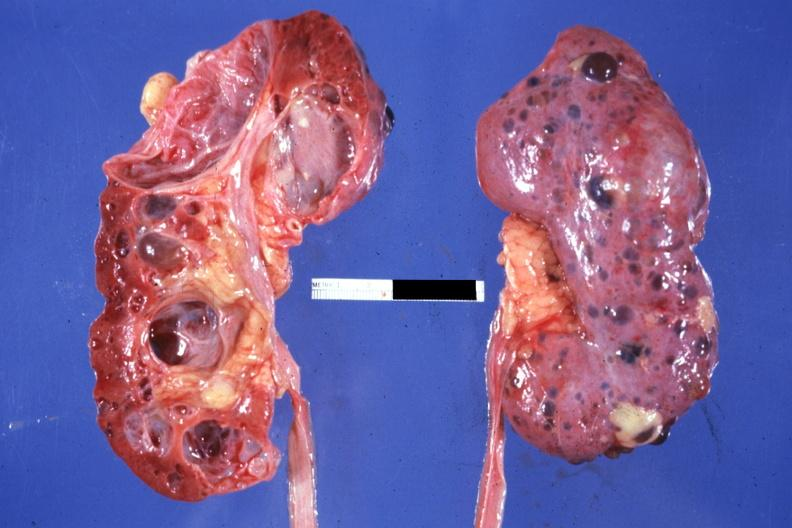what is present?
Answer the question using a single word or phrase. Multicystic 